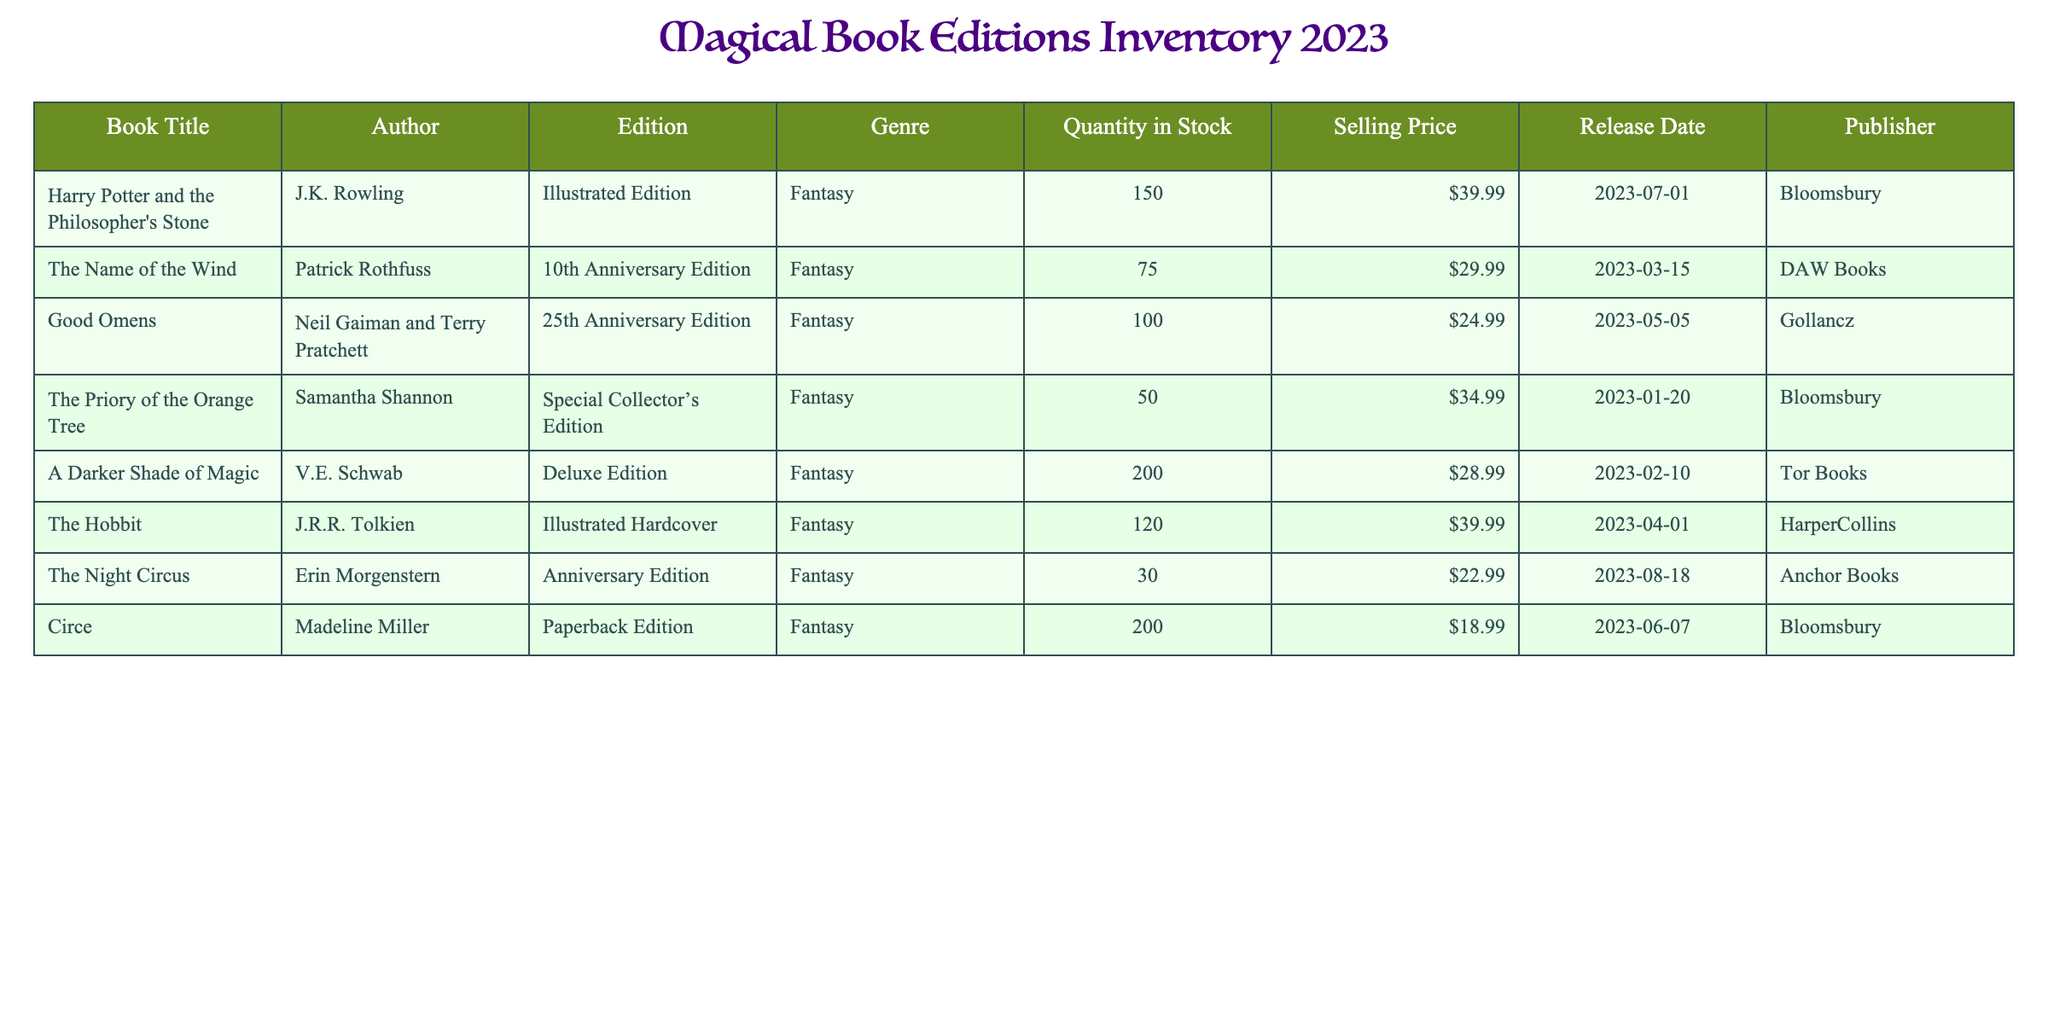What is the selling price of "The Hobbit"? The table directly lists the selling price under the "Selling Price" column for "The Hobbit," which is $39.99.
Answer: $39.99 How many copies of "Circe" are in stock? By looking at the "Quantity in Stock" column for the book "Circe," we can directly see that there are 200 copies available.
Answer: 200 Which book has the lowest selling price? To find the book with the lowest selling price, we compare the "Selling Price" values. The lowest is $18.99 for "Circe."
Answer: Circe What is the total quantity of stock for all editions by Bloomsbury? The books published by Bloomsbury are "Harry Potter and the Philosopher's Stone" (150), "The Priory of the Orange Tree" (50), and "Circe" (200). The total quantity is 150 + 50 + 200 = 400.
Answer: 400 Is "The Night Circus" published by Tor Books? By checking the "Publisher" column for "The Night Circus," we see it is published by Anchor Books, not Tor Books.
Answer: No Which two books together have a total stock of 250? The table shows "Harry Potter and the Philosopher's Stone" with 150 copies and "The Name of the Wind" with 75 copies, summing up to 150 + 75 = 225. However, "A Darker Shade of Magic" has 200 copies; none pairwise totals 250 on inspection.
Answer: None What is the average selling price of the books listed in the inventory? To find the average selling price, we sum the selling prices: 39.99 + 29.99 + 24.99 + 34.99 + 28.99 + 39.99 + 22.99 + 18.99 = 239.92. There are 8 books, so the average is 239.92 / 8 = 29.99.
Answer: $29.99 Which author has more editions listed, J.K. Rowling or Neil Gaiman? J.K. Rowling has 1 edition ("Harry Potter and the Philosopher's Stone"), while Neil Gaiman has 1 edition ("Good Omens") listed, resulting in an equal count.
Answer: Equal 